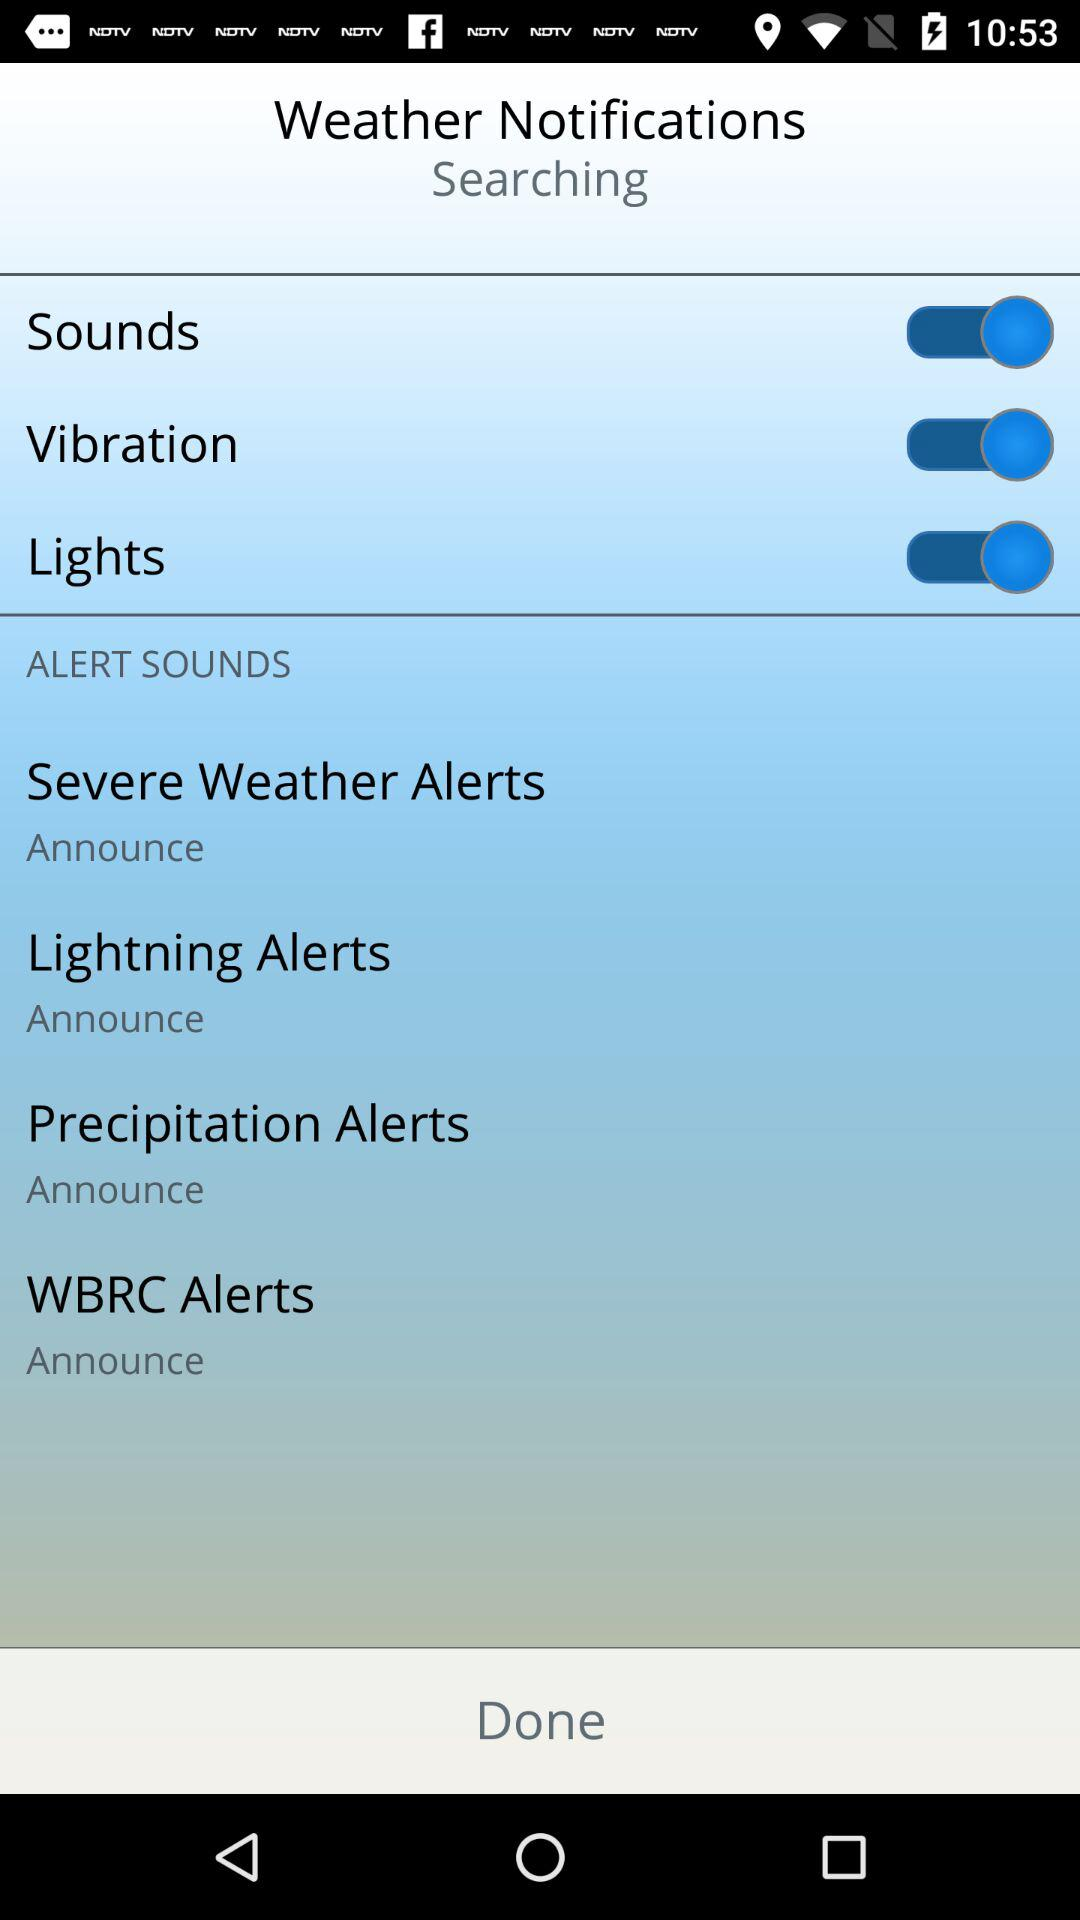What is the status of sounds? The status is on. 